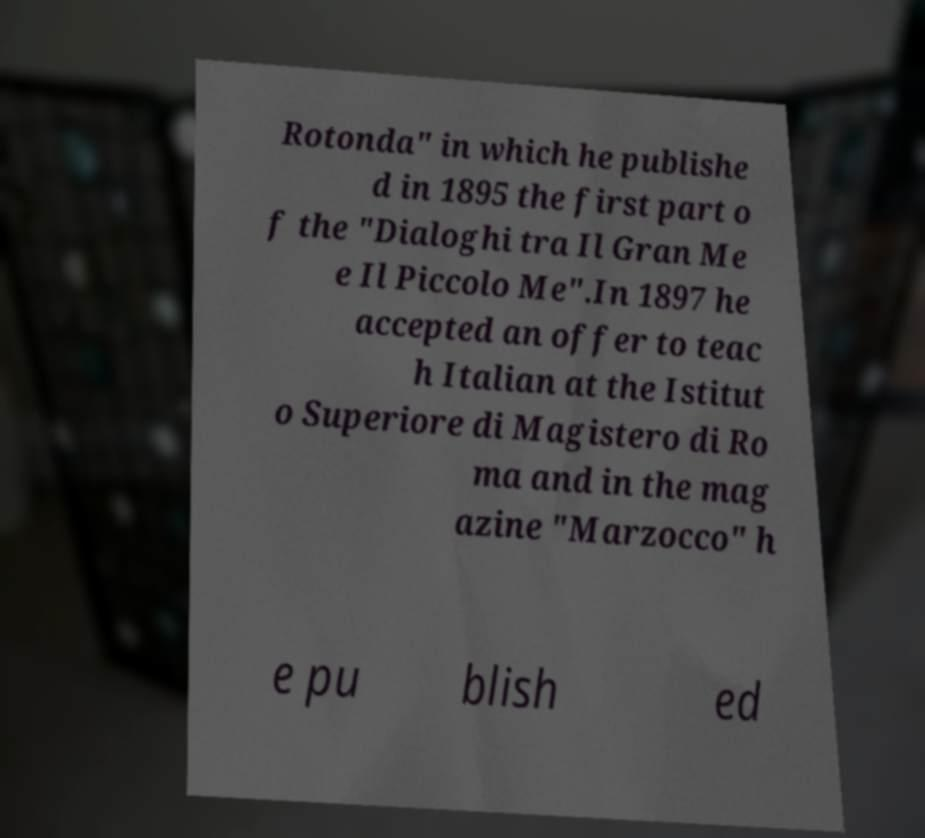There's text embedded in this image that I need extracted. Can you transcribe it verbatim? Rotonda" in which he publishe d in 1895 the first part o f the "Dialoghi tra Il Gran Me e Il Piccolo Me".In 1897 he accepted an offer to teac h Italian at the Istitut o Superiore di Magistero di Ro ma and in the mag azine "Marzocco" h e pu blish ed 